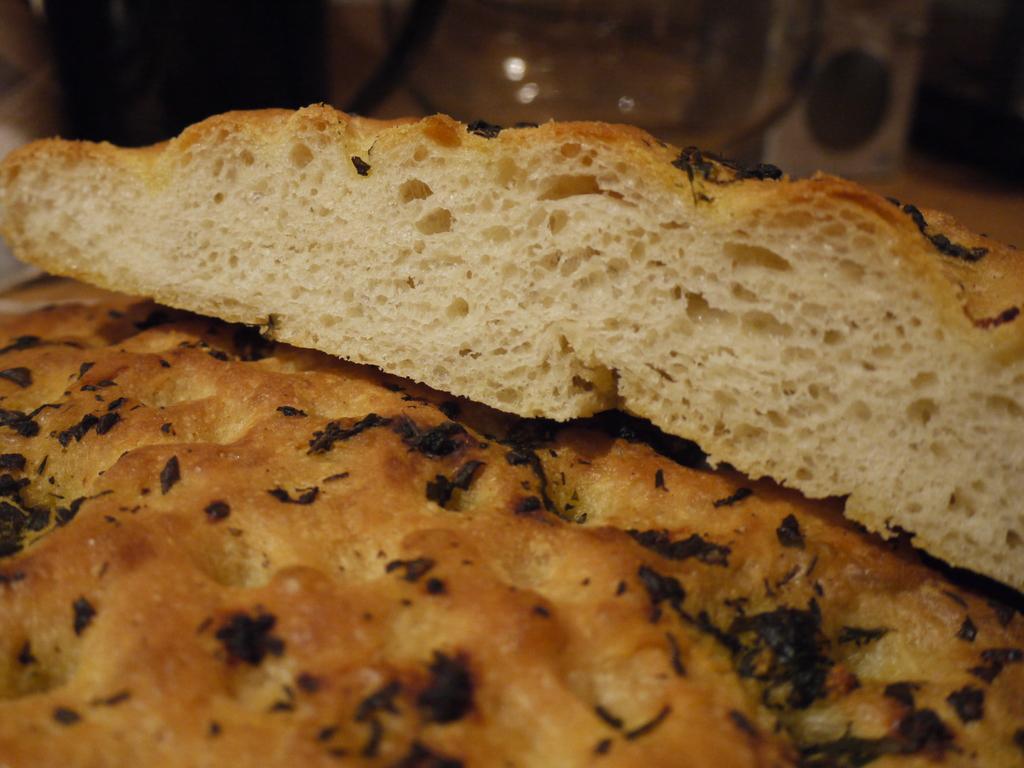Could you give a brief overview of what you see in this image? In this image we can see the food item which looks like a bread and the background image is blurred. 